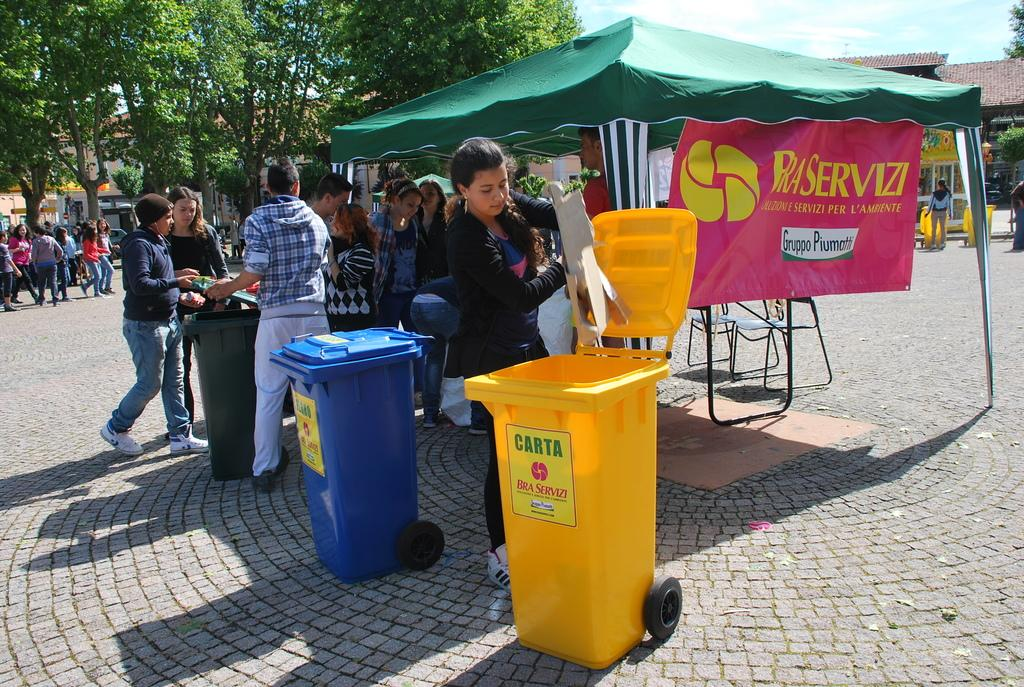<image>
Render a clear and concise summary of the photo. Woman throwing garbgae into a yellow bin that says CARTA on it. 